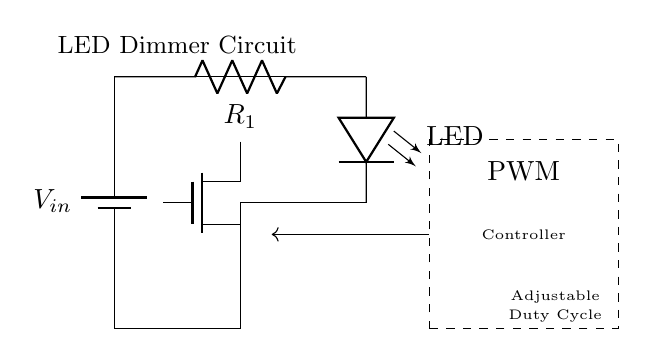What is the type of the controlling component in this circuit? The controlling component is labeled as a PWM Controller, which is responsible for adjusting the brightness of the LED based on the duty cycle of the input signal.
Answer: PWM Controller What is the function of the MOSFET in this circuit? The MOSFET acts as a switch that regulates the amount of current supplied to the LED. When triggered by the PWM signal, it changes its resistance, allowing for variable brightness of the LED.
Answer: Switch What does the dashed rectangle represent? The dashed rectangle encloses the PWM Controller, indicating that it is a distinct module that interfaces with the rest of the circuit to manage light intensity.
Answer: PWM Controller module Which component is directly connected to the LED? The resistor, labeled as R1, is directly connected to the LED, limiting the current passing through the LED to protect it from excessive current that could cause damage.
Answer: Resistor What is the purpose of the adjustable duty cycle in this circuit? The adjustable duty cycle allows varying the width of the PWM signal, which in turn adjusts the average power delivered to the LED, thus controlling its brightness effectively in a home office setting.
Answer: Adjusts brightness How is the power source connected in this circuit? The battery labeled as Vin is connected at the beginning of the circuit, providing the necessary voltage for the operation of both the LED and the controlling components.
Answer: Connected to components What is the orientation of the LED in the circuit? The LED is oriented vertically, with its anode connected to the positive supply voltage and its cathode connected to the drain of the MOSFET, signifying how it will emit light when current flows through it.
Answer: Vertical orientation 